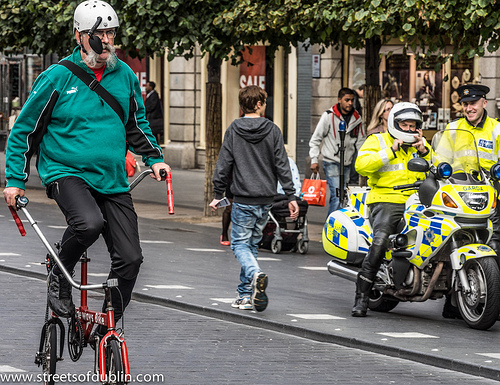<image>
Is there a boy on the bicycle? No. The boy is not positioned on the bicycle. They may be near each other, but the boy is not supported by or resting on top of the bicycle. 